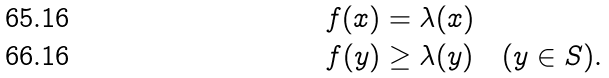<formula> <loc_0><loc_0><loc_500><loc_500>f ( x ) & = \lambda ( x ) \\ f ( y ) & \geq \lambda ( y ) \quad ( y \in S ) .</formula> 